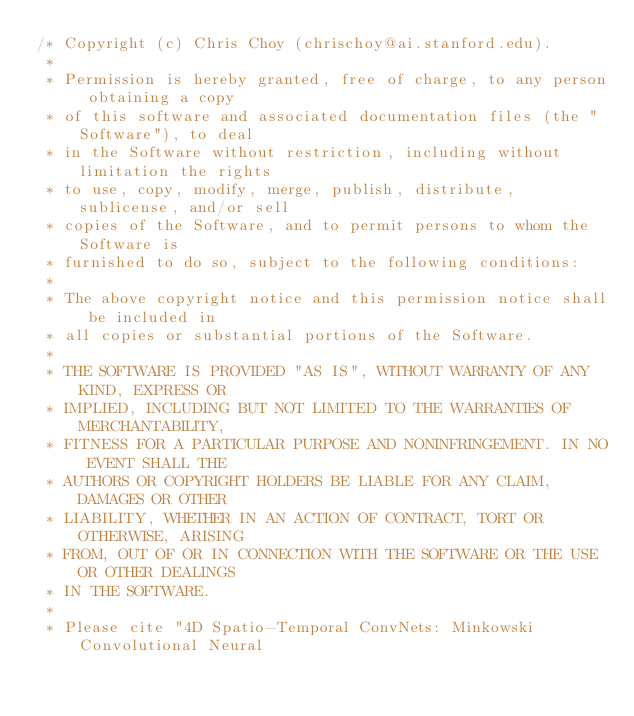Convert code to text. <code><loc_0><loc_0><loc_500><loc_500><_C++_>/* Copyright (c) Chris Choy (chrischoy@ai.stanford.edu).
 *
 * Permission is hereby granted, free of charge, to any person obtaining a copy
 * of this software and associated documentation files (the "Software"), to deal
 * in the Software without restriction, including without limitation the rights
 * to use, copy, modify, merge, publish, distribute, sublicense, and/or sell
 * copies of the Software, and to permit persons to whom the Software is
 * furnished to do so, subject to the following conditions:
 *
 * The above copyright notice and this permission notice shall be included in
 * all copies or substantial portions of the Software.
 *
 * THE SOFTWARE IS PROVIDED "AS IS", WITHOUT WARRANTY OF ANY KIND, EXPRESS OR
 * IMPLIED, INCLUDING BUT NOT LIMITED TO THE WARRANTIES OF MERCHANTABILITY,
 * FITNESS FOR A PARTICULAR PURPOSE AND NONINFRINGEMENT. IN NO EVENT SHALL THE
 * AUTHORS OR COPYRIGHT HOLDERS BE LIABLE FOR ANY CLAIM, DAMAGES OR OTHER
 * LIABILITY, WHETHER IN AN ACTION OF CONTRACT, TORT OR OTHERWISE, ARISING
 * FROM, OUT OF OR IN CONNECTION WITH THE SOFTWARE OR THE USE OR OTHER DEALINGS
 * IN THE SOFTWARE.
 *
 * Please cite "4D Spatio-Temporal ConvNets: Minkowski Convolutional Neural</code> 